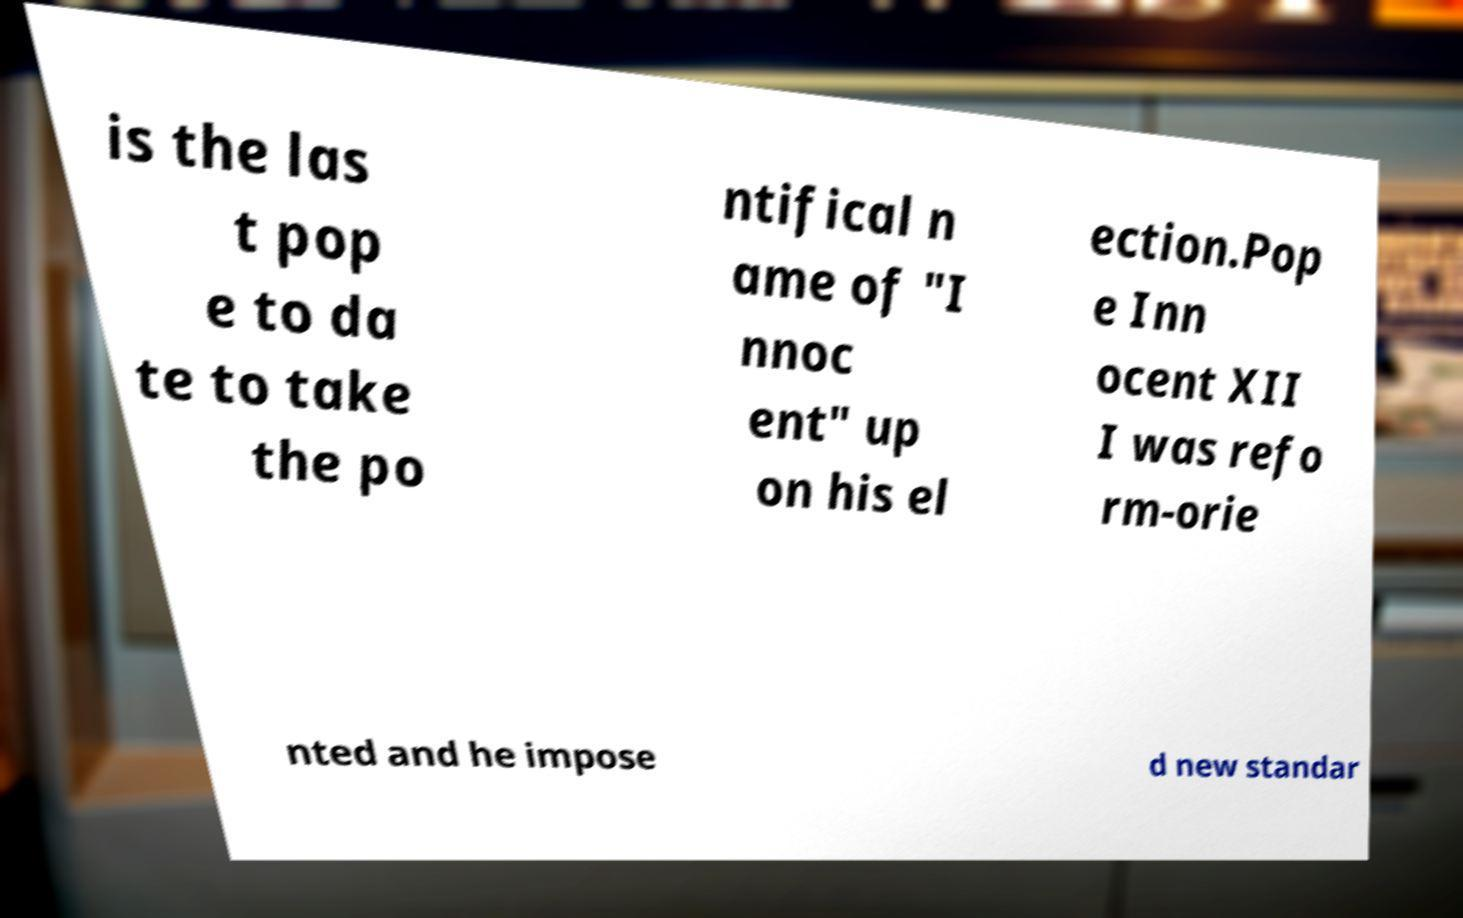Can you read and provide the text displayed in the image?This photo seems to have some interesting text. Can you extract and type it out for me? is the las t pop e to da te to take the po ntifical n ame of "I nnoc ent" up on his el ection.Pop e Inn ocent XII I was refo rm-orie nted and he impose d new standar 